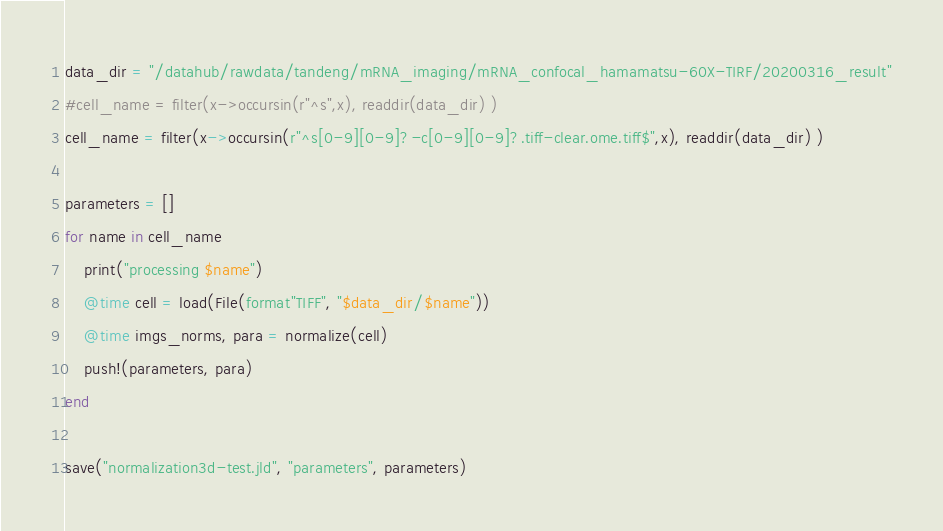<code> <loc_0><loc_0><loc_500><loc_500><_Julia_>data_dir = "/datahub/rawdata/tandeng/mRNA_imaging/mRNA_confocal_hamamatsu-60X-TIRF/20200316_result"
#cell_name = filter(x->occursin(r"^s",x), readdir(data_dir) )
cell_name = filter(x->occursin(r"^s[0-9][0-9]?-c[0-9][0-9]?.tiff-clear.ome.tiff$",x), readdir(data_dir) )

parameters = []
for name in cell_name
	print("processing $name")
	@time cell = load(File(format"TIFF", "$data_dir/$name"))
	@time imgs_norms, para = normalize(cell)
	push!(parameters, para)
end

save("normalization3d-test.jld", "parameters", parameters)
</code> 